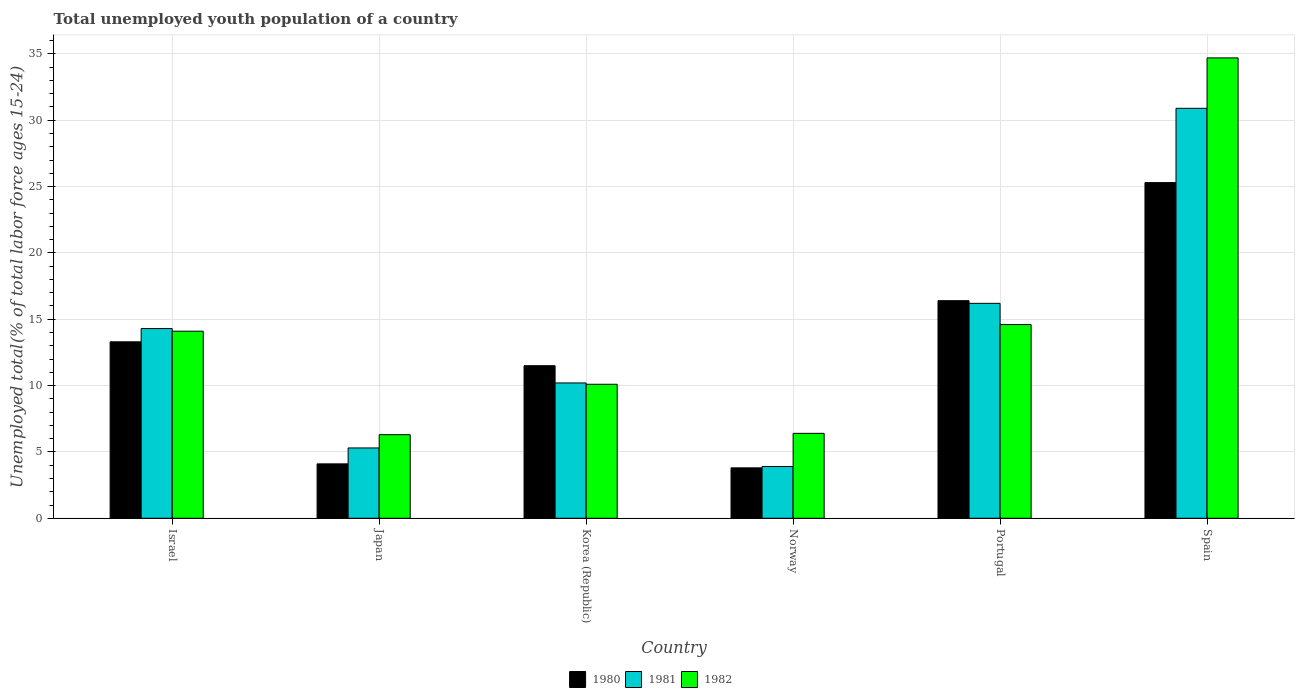How many different coloured bars are there?
Your answer should be compact. 3. How many bars are there on the 1st tick from the left?
Provide a short and direct response. 3. What is the label of the 4th group of bars from the left?
Offer a very short reply. Norway. What is the percentage of total unemployed youth population of a country in 1980 in Spain?
Keep it short and to the point. 25.3. Across all countries, what is the maximum percentage of total unemployed youth population of a country in 1980?
Give a very brief answer. 25.3. Across all countries, what is the minimum percentage of total unemployed youth population of a country in 1982?
Your answer should be compact. 6.3. In which country was the percentage of total unemployed youth population of a country in 1982 maximum?
Ensure brevity in your answer.  Spain. In which country was the percentage of total unemployed youth population of a country in 1981 minimum?
Give a very brief answer. Norway. What is the total percentage of total unemployed youth population of a country in 1981 in the graph?
Offer a terse response. 80.8. What is the difference between the percentage of total unemployed youth population of a country in 1980 in Israel and that in Japan?
Provide a short and direct response. 9.2. What is the difference between the percentage of total unemployed youth population of a country in 1980 in Spain and the percentage of total unemployed youth population of a country in 1981 in Norway?
Give a very brief answer. 21.4. What is the average percentage of total unemployed youth population of a country in 1980 per country?
Give a very brief answer. 12.4. What is the difference between the percentage of total unemployed youth population of a country of/in 1981 and percentage of total unemployed youth population of a country of/in 1982 in Korea (Republic)?
Your answer should be very brief. 0.1. In how many countries, is the percentage of total unemployed youth population of a country in 1981 greater than 34 %?
Provide a short and direct response. 0. What is the ratio of the percentage of total unemployed youth population of a country in 1980 in Norway to that in Portugal?
Offer a very short reply. 0.23. Is the difference between the percentage of total unemployed youth population of a country in 1981 in Israel and Portugal greater than the difference between the percentage of total unemployed youth population of a country in 1982 in Israel and Portugal?
Provide a succinct answer. No. What is the difference between the highest and the second highest percentage of total unemployed youth population of a country in 1980?
Your answer should be compact. -8.9. What is the difference between the highest and the lowest percentage of total unemployed youth population of a country in 1980?
Make the answer very short. 21.5. In how many countries, is the percentage of total unemployed youth population of a country in 1981 greater than the average percentage of total unemployed youth population of a country in 1981 taken over all countries?
Ensure brevity in your answer.  3. Is the sum of the percentage of total unemployed youth population of a country in 1980 in Korea (Republic) and Norway greater than the maximum percentage of total unemployed youth population of a country in 1981 across all countries?
Your response must be concise. No. What does the 3rd bar from the left in Spain represents?
Ensure brevity in your answer.  1982. Is it the case that in every country, the sum of the percentage of total unemployed youth population of a country in 1980 and percentage of total unemployed youth population of a country in 1981 is greater than the percentage of total unemployed youth population of a country in 1982?
Your answer should be very brief. Yes. What is the difference between two consecutive major ticks on the Y-axis?
Your answer should be compact. 5. Does the graph contain grids?
Your response must be concise. Yes. Where does the legend appear in the graph?
Offer a very short reply. Bottom center. How are the legend labels stacked?
Your response must be concise. Horizontal. What is the title of the graph?
Ensure brevity in your answer.  Total unemployed youth population of a country. What is the label or title of the X-axis?
Your answer should be very brief. Country. What is the label or title of the Y-axis?
Your response must be concise. Unemployed total(% of total labor force ages 15-24). What is the Unemployed total(% of total labor force ages 15-24) in 1980 in Israel?
Keep it short and to the point. 13.3. What is the Unemployed total(% of total labor force ages 15-24) in 1981 in Israel?
Ensure brevity in your answer.  14.3. What is the Unemployed total(% of total labor force ages 15-24) in 1982 in Israel?
Offer a terse response. 14.1. What is the Unemployed total(% of total labor force ages 15-24) of 1980 in Japan?
Make the answer very short. 4.1. What is the Unemployed total(% of total labor force ages 15-24) of 1981 in Japan?
Offer a very short reply. 5.3. What is the Unemployed total(% of total labor force ages 15-24) of 1982 in Japan?
Provide a succinct answer. 6.3. What is the Unemployed total(% of total labor force ages 15-24) of 1981 in Korea (Republic)?
Make the answer very short. 10.2. What is the Unemployed total(% of total labor force ages 15-24) in 1982 in Korea (Republic)?
Offer a terse response. 10.1. What is the Unemployed total(% of total labor force ages 15-24) of 1980 in Norway?
Offer a terse response. 3.8. What is the Unemployed total(% of total labor force ages 15-24) of 1981 in Norway?
Your answer should be very brief. 3.9. What is the Unemployed total(% of total labor force ages 15-24) in 1982 in Norway?
Offer a terse response. 6.4. What is the Unemployed total(% of total labor force ages 15-24) of 1980 in Portugal?
Ensure brevity in your answer.  16.4. What is the Unemployed total(% of total labor force ages 15-24) in 1981 in Portugal?
Give a very brief answer. 16.2. What is the Unemployed total(% of total labor force ages 15-24) in 1982 in Portugal?
Provide a short and direct response. 14.6. What is the Unemployed total(% of total labor force ages 15-24) in 1980 in Spain?
Your answer should be compact. 25.3. What is the Unemployed total(% of total labor force ages 15-24) in 1981 in Spain?
Offer a terse response. 30.9. What is the Unemployed total(% of total labor force ages 15-24) of 1982 in Spain?
Your response must be concise. 34.7. Across all countries, what is the maximum Unemployed total(% of total labor force ages 15-24) in 1980?
Offer a very short reply. 25.3. Across all countries, what is the maximum Unemployed total(% of total labor force ages 15-24) in 1981?
Your answer should be compact. 30.9. Across all countries, what is the maximum Unemployed total(% of total labor force ages 15-24) in 1982?
Provide a short and direct response. 34.7. Across all countries, what is the minimum Unemployed total(% of total labor force ages 15-24) in 1980?
Ensure brevity in your answer.  3.8. Across all countries, what is the minimum Unemployed total(% of total labor force ages 15-24) in 1981?
Offer a very short reply. 3.9. Across all countries, what is the minimum Unemployed total(% of total labor force ages 15-24) in 1982?
Your answer should be very brief. 6.3. What is the total Unemployed total(% of total labor force ages 15-24) in 1980 in the graph?
Offer a terse response. 74.4. What is the total Unemployed total(% of total labor force ages 15-24) of 1981 in the graph?
Keep it short and to the point. 80.8. What is the total Unemployed total(% of total labor force ages 15-24) of 1982 in the graph?
Give a very brief answer. 86.2. What is the difference between the Unemployed total(% of total labor force ages 15-24) in 1981 in Israel and that in Japan?
Offer a terse response. 9. What is the difference between the Unemployed total(% of total labor force ages 15-24) in 1982 in Israel and that in Japan?
Your response must be concise. 7.8. What is the difference between the Unemployed total(% of total labor force ages 15-24) in 1981 in Israel and that in Korea (Republic)?
Ensure brevity in your answer.  4.1. What is the difference between the Unemployed total(% of total labor force ages 15-24) of 1982 in Israel and that in Korea (Republic)?
Keep it short and to the point. 4. What is the difference between the Unemployed total(% of total labor force ages 15-24) in 1981 in Israel and that in Norway?
Your response must be concise. 10.4. What is the difference between the Unemployed total(% of total labor force ages 15-24) of 1982 in Israel and that in Norway?
Your answer should be compact. 7.7. What is the difference between the Unemployed total(% of total labor force ages 15-24) of 1981 in Israel and that in Portugal?
Offer a terse response. -1.9. What is the difference between the Unemployed total(% of total labor force ages 15-24) in 1982 in Israel and that in Portugal?
Offer a terse response. -0.5. What is the difference between the Unemployed total(% of total labor force ages 15-24) in 1981 in Israel and that in Spain?
Make the answer very short. -16.6. What is the difference between the Unemployed total(% of total labor force ages 15-24) in 1982 in Israel and that in Spain?
Keep it short and to the point. -20.6. What is the difference between the Unemployed total(% of total labor force ages 15-24) in 1981 in Japan and that in Korea (Republic)?
Keep it short and to the point. -4.9. What is the difference between the Unemployed total(% of total labor force ages 15-24) in 1982 in Japan and that in Norway?
Offer a terse response. -0.1. What is the difference between the Unemployed total(% of total labor force ages 15-24) in 1981 in Japan and that in Portugal?
Your answer should be very brief. -10.9. What is the difference between the Unemployed total(% of total labor force ages 15-24) in 1982 in Japan and that in Portugal?
Offer a terse response. -8.3. What is the difference between the Unemployed total(% of total labor force ages 15-24) in 1980 in Japan and that in Spain?
Keep it short and to the point. -21.2. What is the difference between the Unemployed total(% of total labor force ages 15-24) of 1981 in Japan and that in Spain?
Give a very brief answer. -25.6. What is the difference between the Unemployed total(% of total labor force ages 15-24) of 1982 in Japan and that in Spain?
Your answer should be compact. -28.4. What is the difference between the Unemployed total(% of total labor force ages 15-24) of 1982 in Korea (Republic) and that in Norway?
Give a very brief answer. 3.7. What is the difference between the Unemployed total(% of total labor force ages 15-24) in 1982 in Korea (Republic) and that in Portugal?
Offer a terse response. -4.5. What is the difference between the Unemployed total(% of total labor force ages 15-24) in 1981 in Korea (Republic) and that in Spain?
Ensure brevity in your answer.  -20.7. What is the difference between the Unemployed total(% of total labor force ages 15-24) of 1982 in Korea (Republic) and that in Spain?
Offer a terse response. -24.6. What is the difference between the Unemployed total(% of total labor force ages 15-24) of 1981 in Norway and that in Portugal?
Make the answer very short. -12.3. What is the difference between the Unemployed total(% of total labor force ages 15-24) in 1980 in Norway and that in Spain?
Provide a short and direct response. -21.5. What is the difference between the Unemployed total(% of total labor force ages 15-24) of 1981 in Norway and that in Spain?
Your response must be concise. -27. What is the difference between the Unemployed total(% of total labor force ages 15-24) of 1982 in Norway and that in Spain?
Your answer should be very brief. -28.3. What is the difference between the Unemployed total(% of total labor force ages 15-24) of 1980 in Portugal and that in Spain?
Provide a short and direct response. -8.9. What is the difference between the Unemployed total(% of total labor force ages 15-24) in 1981 in Portugal and that in Spain?
Your answer should be compact. -14.7. What is the difference between the Unemployed total(% of total labor force ages 15-24) in 1982 in Portugal and that in Spain?
Offer a very short reply. -20.1. What is the difference between the Unemployed total(% of total labor force ages 15-24) of 1980 in Israel and the Unemployed total(% of total labor force ages 15-24) of 1981 in Japan?
Your answer should be very brief. 8. What is the difference between the Unemployed total(% of total labor force ages 15-24) of 1980 in Israel and the Unemployed total(% of total labor force ages 15-24) of 1981 in Korea (Republic)?
Your response must be concise. 3.1. What is the difference between the Unemployed total(% of total labor force ages 15-24) of 1980 in Israel and the Unemployed total(% of total labor force ages 15-24) of 1982 in Korea (Republic)?
Offer a very short reply. 3.2. What is the difference between the Unemployed total(% of total labor force ages 15-24) of 1980 in Israel and the Unemployed total(% of total labor force ages 15-24) of 1981 in Norway?
Your response must be concise. 9.4. What is the difference between the Unemployed total(% of total labor force ages 15-24) in 1981 in Israel and the Unemployed total(% of total labor force ages 15-24) in 1982 in Norway?
Provide a succinct answer. 7.9. What is the difference between the Unemployed total(% of total labor force ages 15-24) of 1981 in Israel and the Unemployed total(% of total labor force ages 15-24) of 1982 in Portugal?
Offer a terse response. -0.3. What is the difference between the Unemployed total(% of total labor force ages 15-24) of 1980 in Israel and the Unemployed total(% of total labor force ages 15-24) of 1981 in Spain?
Provide a short and direct response. -17.6. What is the difference between the Unemployed total(% of total labor force ages 15-24) in 1980 in Israel and the Unemployed total(% of total labor force ages 15-24) in 1982 in Spain?
Offer a very short reply. -21.4. What is the difference between the Unemployed total(% of total labor force ages 15-24) in 1981 in Israel and the Unemployed total(% of total labor force ages 15-24) in 1982 in Spain?
Make the answer very short. -20.4. What is the difference between the Unemployed total(% of total labor force ages 15-24) of 1980 in Japan and the Unemployed total(% of total labor force ages 15-24) of 1981 in Korea (Republic)?
Provide a short and direct response. -6.1. What is the difference between the Unemployed total(% of total labor force ages 15-24) in 1980 in Japan and the Unemployed total(% of total labor force ages 15-24) in 1982 in Korea (Republic)?
Offer a very short reply. -6. What is the difference between the Unemployed total(% of total labor force ages 15-24) in 1981 in Japan and the Unemployed total(% of total labor force ages 15-24) in 1982 in Korea (Republic)?
Keep it short and to the point. -4.8. What is the difference between the Unemployed total(% of total labor force ages 15-24) of 1980 in Japan and the Unemployed total(% of total labor force ages 15-24) of 1982 in Norway?
Provide a short and direct response. -2.3. What is the difference between the Unemployed total(% of total labor force ages 15-24) in 1981 in Japan and the Unemployed total(% of total labor force ages 15-24) in 1982 in Norway?
Provide a succinct answer. -1.1. What is the difference between the Unemployed total(% of total labor force ages 15-24) of 1980 in Japan and the Unemployed total(% of total labor force ages 15-24) of 1982 in Portugal?
Your answer should be very brief. -10.5. What is the difference between the Unemployed total(% of total labor force ages 15-24) in 1981 in Japan and the Unemployed total(% of total labor force ages 15-24) in 1982 in Portugal?
Your answer should be compact. -9.3. What is the difference between the Unemployed total(% of total labor force ages 15-24) in 1980 in Japan and the Unemployed total(% of total labor force ages 15-24) in 1981 in Spain?
Give a very brief answer. -26.8. What is the difference between the Unemployed total(% of total labor force ages 15-24) of 1980 in Japan and the Unemployed total(% of total labor force ages 15-24) of 1982 in Spain?
Provide a short and direct response. -30.6. What is the difference between the Unemployed total(% of total labor force ages 15-24) in 1981 in Japan and the Unemployed total(% of total labor force ages 15-24) in 1982 in Spain?
Offer a very short reply. -29.4. What is the difference between the Unemployed total(% of total labor force ages 15-24) in 1980 in Korea (Republic) and the Unemployed total(% of total labor force ages 15-24) in 1981 in Spain?
Your response must be concise. -19.4. What is the difference between the Unemployed total(% of total labor force ages 15-24) in 1980 in Korea (Republic) and the Unemployed total(% of total labor force ages 15-24) in 1982 in Spain?
Your answer should be very brief. -23.2. What is the difference between the Unemployed total(% of total labor force ages 15-24) of 1981 in Korea (Republic) and the Unemployed total(% of total labor force ages 15-24) of 1982 in Spain?
Give a very brief answer. -24.5. What is the difference between the Unemployed total(% of total labor force ages 15-24) in 1980 in Norway and the Unemployed total(% of total labor force ages 15-24) in 1981 in Spain?
Make the answer very short. -27.1. What is the difference between the Unemployed total(% of total labor force ages 15-24) in 1980 in Norway and the Unemployed total(% of total labor force ages 15-24) in 1982 in Spain?
Keep it short and to the point. -30.9. What is the difference between the Unemployed total(% of total labor force ages 15-24) of 1981 in Norway and the Unemployed total(% of total labor force ages 15-24) of 1982 in Spain?
Your answer should be very brief. -30.8. What is the difference between the Unemployed total(% of total labor force ages 15-24) in 1980 in Portugal and the Unemployed total(% of total labor force ages 15-24) in 1981 in Spain?
Provide a succinct answer. -14.5. What is the difference between the Unemployed total(% of total labor force ages 15-24) in 1980 in Portugal and the Unemployed total(% of total labor force ages 15-24) in 1982 in Spain?
Provide a short and direct response. -18.3. What is the difference between the Unemployed total(% of total labor force ages 15-24) of 1981 in Portugal and the Unemployed total(% of total labor force ages 15-24) of 1982 in Spain?
Your answer should be very brief. -18.5. What is the average Unemployed total(% of total labor force ages 15-24) of 1981 per country?
Ensure brevity in your answer.  13.47. What is the average Unemployed total(% of total labor force ages 15-24) in 1982 per country?
Give a very brief answer. 14.37. What is the difference between the Unemployed total(% of total labor force ages 15-24) in 1981 and Unemployed total(% of total labor force ages 15-24) in 1982 in Japan?
Provide a short and direct response. -1. What is the difference between the Unemployed total(% of total labor force ages 15-24) in 1980 and Unemployed total(% of total labor force ages 15-24) in 1981 in Korea (Republic)?
Your response must be concise. 1.3. What is the difference between the Unemployed total(% of total labor force ages 15-24) of 1980 and Unemployed total(% of total labor force ages 15-24) of 1981 in Norway?
Ensure brevity in your answer.  -0.1. What is the difference between the Unemployed total(% of total labor force ages 15-24) of 1981 and Unemployed total(% of total labor force ages 15-24) of 1982 in Norway?
Ensure brevity in your answer.  -2.5. What is the difference between the Unemployed total(% of total labor force ages 15-24) in 1981 and Unemployed total(% of total labor force ages 15-24) in 1982 in Portugal?
Make the answer very short. 1.6. What is the difference between the Unemployed total(% of total labor force ages 15-24) of 1980 and Unemployed total(% of total labor force ages 15-24) of 1981 in Spain?
Keep it short and to the point. -5.6. What is the ratio of the Unemployed total(% of total labor force ages 15-24) in 1980 in Israel to that in Japan?
Provide a short and direct response. 3.24. What is the ratio of the Unemployed total(% of total labor force ages 15-24) of 1981 in Israel to that in Japan?
Keep it short and to the point. 2.7. What is the ratio of the Unemployed total(% of total labor force ages 15-24) of 1982 in Israel to that in Japan?
Provide a short and direct response. 2.24. What is the ratio of the Unemployed total(% of total labor force ages 15-24) of 1980 in Israel to that in Korea (Republic)?
Your response must be concise. 1.16. What is the ratio of the Unemployed total(% of total labor force ages 15-24) of 1981 in Israel to that in Korea (Republic)?
Give a very brief answer. 1.4. What is the ratio of the Unemployed total(% of total labor force ages 15-24) in 1982 in Israel to that in Korea (Republic)?
Ensure brevity in your answer.  1.4. What is the ratio of the Unemployed total(% of total labor force ages 15-24) in 1980 in Israel to that in Norway?
Your response must be concise. 3.5. What is the ratio of the Unemployed total(% of total labor force ages 15-24) of 1981 in Israel to that in Norway?
Your answer should be very brief. 3.67. What is the ratio of the Unemployed total(% of total labor force ages 15-24) in 1982 in Israel to that in Norway?
Give a very brief answer. 2.2. What is the ratio of the Unemployed total(% of total labor force ages 15-24) of 1980 in Israel to that in Portugal?
Give a very brief answer. 0.81. What is the ratio of the Unemployed total(% of total labor force ages 15-24) in 1981 in Israel to that in Portugal?
Keep it short and to the point. 0.88. What is the ratio of the Unemployed total(% of total labor force ages 15-24) of 1982 in Israel to that in Portugal?
Make the answer very short. 0.97. What is the ratio of the Unemployed total(% of total labor force ages 15-24) in 1980 in Israel to that in Spain?
Give a very brief answer. 0.53. What is the ratio of the Unemployed total(% of total labor force ages 15-24) of 1981 in Israel to that in Spain?
Keep it short and to the point. 0.46. What is the ratio of the Unemployed total(% of total labor force ages 15-24) of 1982 in Israel to that in Spain?
Your answer should be very brief. 0.41. What is the ratio of the Unemployed total(% of total labor force ages 15-24) in 1980 in Japan to that in Korea (Republic)?
Your answer should be very brief. 0.36. What is the ratio of the Unemployed total(% of total labor force ages 15-24) in 1981 in Japan to that in Korea (Republic)?
Keep it short and to the point. 0.52. What is the ratio of the Unemployed total(% of total labor force ages 15-24) in 1982 in Japan to that in Korea (Republic)?
Make the answer very short. 0.62. What is the ratio of the Unemployed total(% of total labor force ages 15-24) of 1980 in Japan to that in Norway?
Make the answer very short. 1.08. What is the ratio of the Unemployed total(% of total labor force ages 15-24) of 1981 in Japan to that in Norway?
Ensure brevity in your answer.  1.36. What is the ratio of the Unemployed total(% of total labor force ages 15-24) of 1982 in Japan to that in Norway?
Make the answer very short. 0.98. What is the ratio of the Unemployed total(% of total labor force ages 15-24) in 1980 in Japan to that in Portugal?
Offer a terse response. 0.25. What is the ratio of the Unemployed total(% of total labor force ages 15-24) in 1981 in Japan to that in Portugal?
Provide a short and direct response. 0.33. What is the ratio of the Unemployed total(% of total labor force ages 15-24) of 1982 in Japan to that in Portugal?
Offer a terse response. 0.43. What is the ratio of the Unemployed total(% of total labor force ages 15-24) in 1980 in Japan to that in Spain?
Ensure brevity in your answer.  0.16. What is the ratio of the Unemployed total(% of total labor force ages 15-24) of 1981 in Japan to that in Spain?
Make the answer very short. 0.17. What is the ratio of the Unemployed total(% of total labor force ages 15-24) of 1982 in Japan to that in Spain?
Your answer should be very brief. 0.18. What is the ratio of the Unemployed total(% of total labor force ages 15-24) in 1980 in Korea (Republic) to that in Norway?
Your answer should be very brief. 3.03. What is the ratio of the Unemployed total(% of total labor force ages 15-24) in 1981 in Korea (Republic) to that in Norway?
Offer a very short reply. 2.62. What is the ratio of the Unemployed total(% of total labor force ages 15-24) in 1982 in Korea (Republic) to that in Norway?
Your response must be concise. 1.58. What is the ratio of the Unemployed total(% of total labor force ages 15-24) in 1980 in Korea (Republic) to that in Portugal?
Provide a succinct answer. 0.7. What is the ratio of the Unemployed total(% of total labor force ages 15-24) in 1981 in Korea (Republic) to that in Portugal?
Ensure brevity in your answer.  0.63. What is the ratio of the Unemployed total(% of total labor force ages 15-24) of 1982 in Korea (Republic) to that in Portugal?
Offer a very short reply. 0.69. What is the ratio of the Unemployed total(% of total labor force ages 15-24) of 1980 in Korea (Republic) to that in Spain?
Give a very brief answer. 0.45. What is the ratio of the Unemployed total(% of total labor force ages 15-24) of 1981 in Korea (Republic) to that in Spain?
Provide a short and direct response. 0.33. What is the ratio of the Unemployed total(% of total labor force ages 15-24) in 1982 in Korea (Republic) to that in Spain?
Offer a terse response. 0.29. What is the ratio of the Unemployed total(% of total labor force ages 15-24) in 1980 in Norway to that in Portugal?
Your answer should be very brief. 0.23. What is the ratio of the Unemployed total(% of total labor force ages 15-24) in 1981 in Norway to that in Portugal?
Keep it short and to the point. 0.24. What is the ratio of the Unemployed total(% of total labor force ages 15-24) of 1982 in Norway to that in Portugal?
Your response must be concise. 0.44. What is the ratio of the Unemployed total(% of total labor force ages 15-24) in 1980 in Norway to that in Spain?
Provide a short and direct response. 0.15. What is the ratio of the Unemployed total(% of total labor force ages 15-24) of 1981 in Norway to that in Spain?
Provide a short and direct response. 0.13. What is the ratio of the Unemployed total(% of total labor force ages 15-24) of 1982 in Norway to that in Spain?
Provide a succinct answer. 0.18. What is the ratio of the Unemployed total(% of total labor force ages 15-24) of 1980 in Portugal to that in Spain?
Your answer should be very brief. 0.65. What is the ratio of the Unemployed total(% of total labor force ages 15-24) of 1981 in Portugal to that in Spain?
Provide a succinct answer. 0.52. What is the ratio of the Unemployed total(% of total labor force ages 15-24) in 1982 in Portugal to that in Spain?
Offer a very short reply. 0.42. What is the difference between the highest and the second highest Unemployed total(% of total labor force ages 15-24) in 1980?
Your response must be concise. 8.9. What is the difference between the highest and the second highest Unemployed total(% of total labor force ages 15-24) of 1981?
Give a very brief answer. 14.7. What is the difference between the highest and the second highest Unemployed total(% of total labor force ages 15-24) in 1982?
Your answer should be compact. 20.1. What is the difference between the highest and the lowest Unemployed total(% of total labor force ages 15-24) of 1980?
Make the answer very short. 21.5. What is the difference between the highest and the lowest Unemployed total(% of total labor force ages 15-24) of 1981?
Your answer should be compact. 27. What is the difference between the highest and the lowest Unemployed total(% of total labor force ages 15-24) of 1982?
Provide a short and direct response. 28.4. 